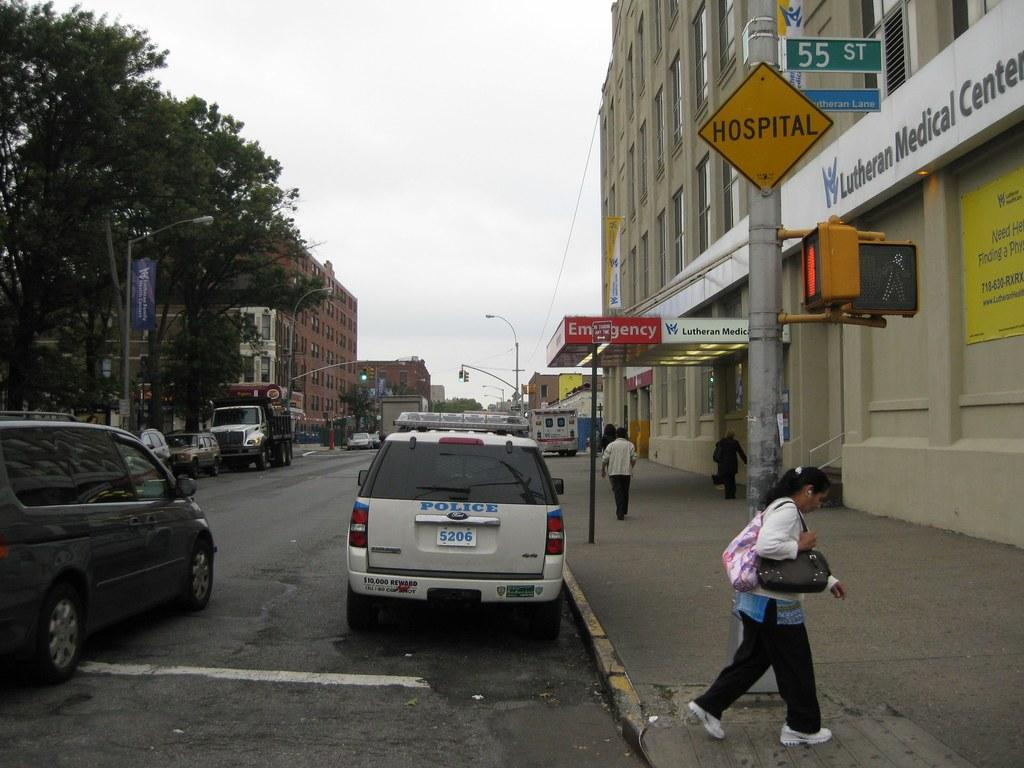Provide a one-sentence caption for the provided image. A woman walks under a yellow sign that displays the word HOSPITAL on it. 